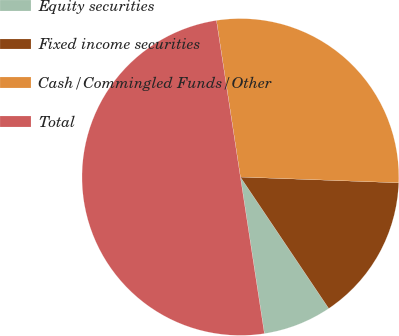Convert chart to OTSL. <chart><loc_0><loc_0><loc_500><loc_500><pie_chart><fcel>Equity securities<fcel>Fixed income securities<fcel>Cash/Commingled Funds/Other<fcel>Total<nl><fcel>7.0%<fcel>15.0%<fcel>28.0%<fcel>50.0%<nl></chart> 